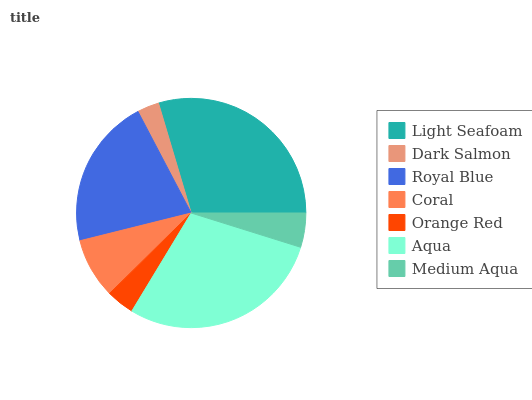Is Dark Salmon the minimum?
Answer yes or no. Yes. Is Light Seafoam the maximum?
Answer yes or no. Yes. Is Royal Blue the minimum?
Answer yes or no. No. Is Royal Blue the maximum?
Answer yes or no. No. Is Royal Blue greater than Dark Salmon?
Answer yes or no. Yes. Is Dark Salmon less than Royal Blue?
Answer yes or no. Yes. Is Dark Salmon greater than Royal Blue?
Answer yes or no. No. Is Royal Blue less than Dark Salmon?
Answer yes or no. No. Is Coral the high median?
Answer yes or no. Yes. Is Coral the low median?
Answer yes or no. Yes. Is Medium Aqua the high median?
Answer yes or no. No. Is Light Seafoam the low median?
Answer yes or no. No. 